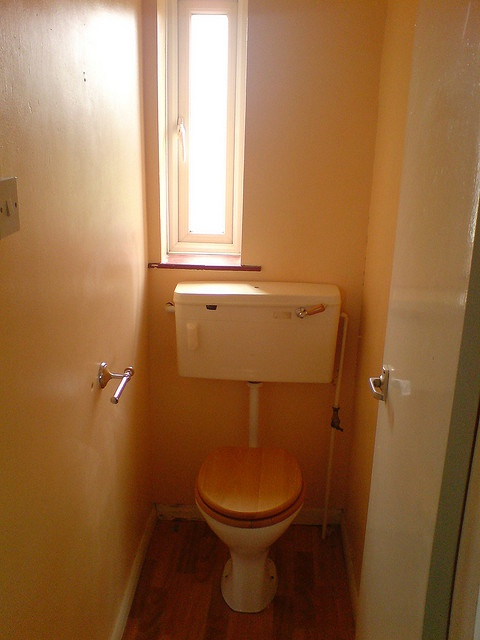Describe the objects in this image and their specific colors. I can see a toilet in gray and maroon tones in this image. 